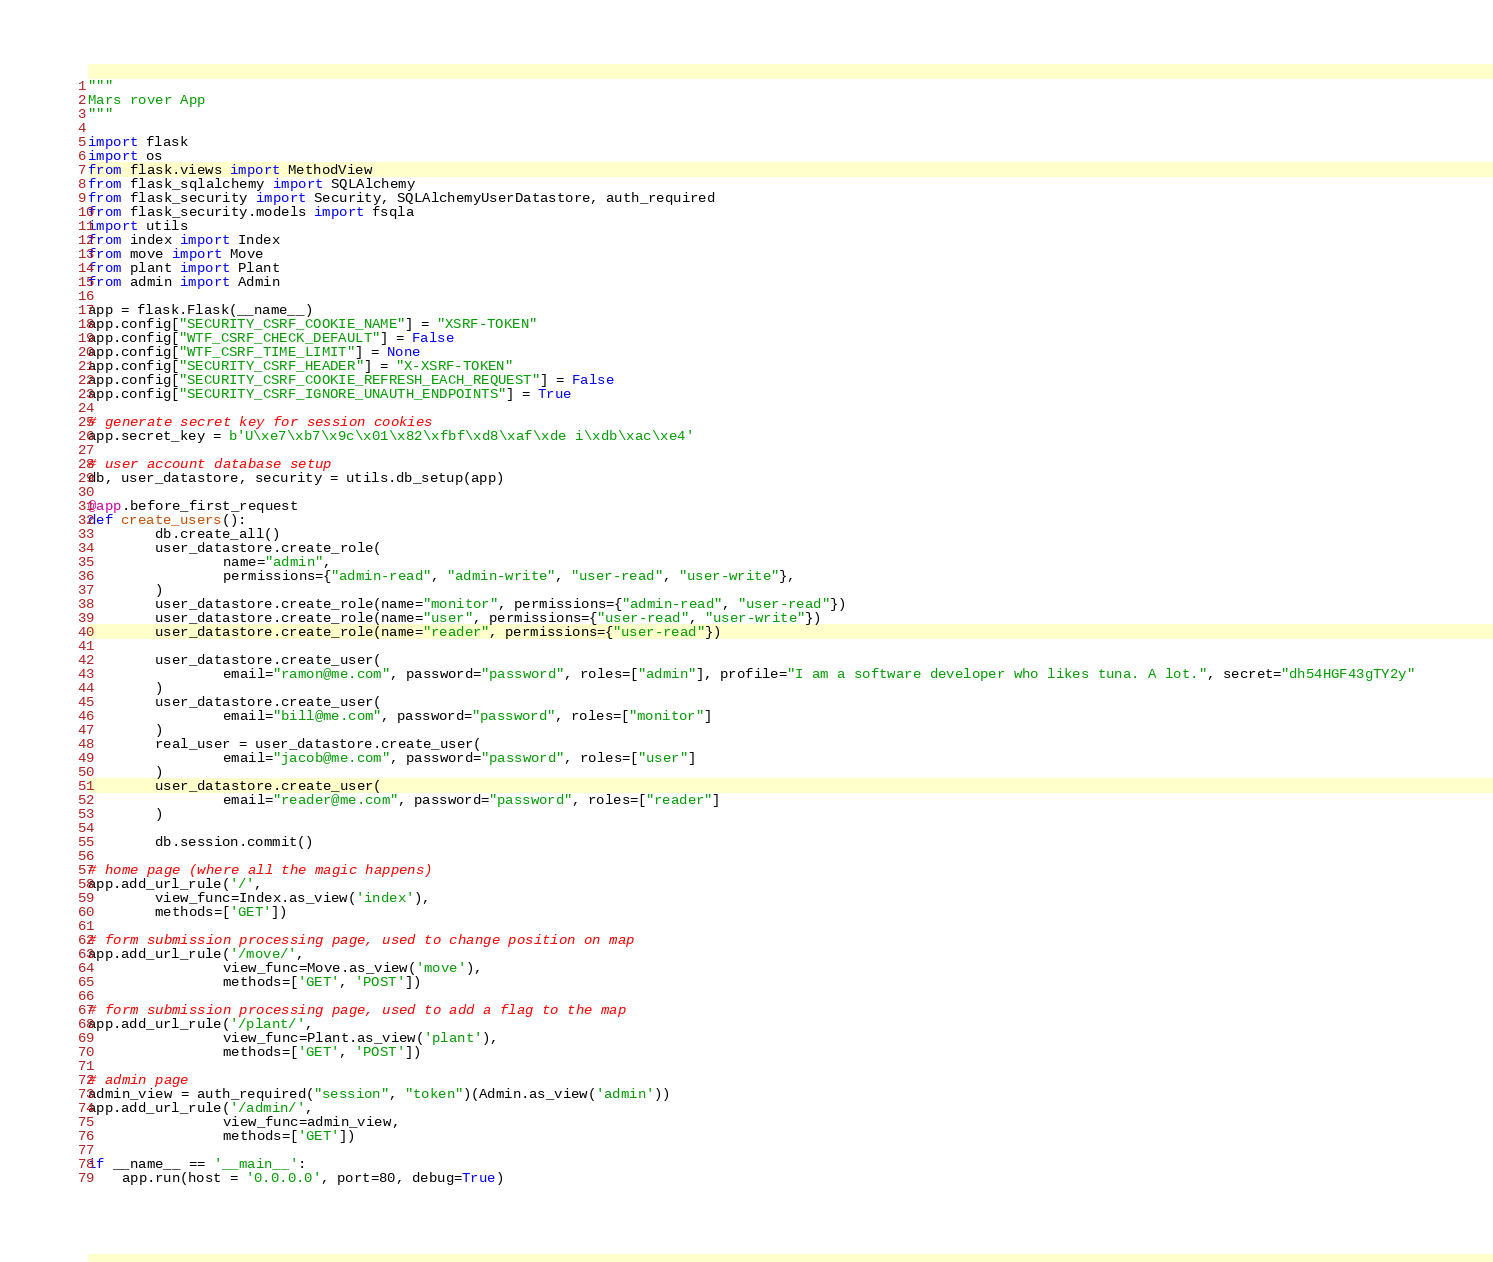<code> <loc_0><loc_0><loc_500><loc_500><_Python_>"""
Mars rover App
"""

import flask
import os
from flask.views import MethodView
from flask_sqlalchemy import SQLAlchemy
from flask_security import Security, SQLAlchemyUserDatastore, auth_required
from flask_security.models import fsqla
import utils
from index import Index
from move import Move
from plant import Plant
from admin import Admin

app = flask.Flask(__name__)
app.config["SECURITY_CSRF_COOKIE_NAME"] = "XSRF-TOKEN"
app.config["WTF_CSRF_CHECK_DEFAULT"] = False
app.config["WTF_CSRF_TIME_LIMIT"] = None
app.config["SECURITY_CSRF_HEADER"] = "X-XSRF-TOKEN"
app.config["SECURITY_CSRF_COOKIE_REFRESH_EACH_REQUEST"] = False
app.config["SECURITY_CSRF_IGNORE_UNAUTH_ENDPOINTS"] = True

# generate secret key for session cookies
app.secret_key = b'U\xe7\xb7\x9c\x01\x82\xfbf\xd8\xaf\xde i\xdb\xac\xe4'

# user account database setup
db, user_datastore, security = utils.db_setup(app)

@app.before_first_request
def create_users():
        db.create_all()
        user_datastore.create_role(
                name="admin",
                permissions={"admin-read", "admin-write", "user-read", "user-write"},
        )
        user_datastore.create_role(name="monitor", permissions={"admin-read", "user-read"})
        user_datastore.create_role(name="user", permissions={"user-read", "user-write"})
        user_datastore.create_role(name="reader", permissions={"user-read"})

        user_datastore.create_user(
                email="ramon@me.com", password="password", roles=["admin"], profile="I am a software developer who likes tuna. A lot.", secret="dh54HGF43gTY2y"
        )
        user_datastore.create_user(
                email="bill@me.com", password="password", roles=["monitor"]
        )
        real_user = user_datastore.create_user(
                email="jacob@me.com", password="password", roles=["user"]
        )
        user_datastore.create_user(
                email="reader@me.com", password="password", roles=["reader"]
        )

        db.session.commit()

# home page (where all the magic happens)
app.add_url_rule('/',
		view_func=Index.as_view('index'),
		methods=['GET'])

# form submission processing page, used to change position on map
app.add_url_rule('/move/',
                view_func=Move.as_view('move'),
                methods=['GET', 'POST'])

# form submission processing page, used to add a flag to the map
app.add_url_rule('/plant/',
                view_func=Plant.as_view('plant'),
                methods=['GET', 'POST'])

# admin page
admin_view = auth_required("session", "token")(Admin.as_view('admin'))
app.add_url_rule('/admin/',
                view_func=admin_view,
                methods=['GET'])

if __name__ == '__main__':
	app.run(host = '0.0.0.0', port=80, debug=True)


</code> 